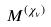<formula> <loc_0><loc_0><loc_500><loc_500>M ^ { ( \chi _ { \nu } ) }</formula> 